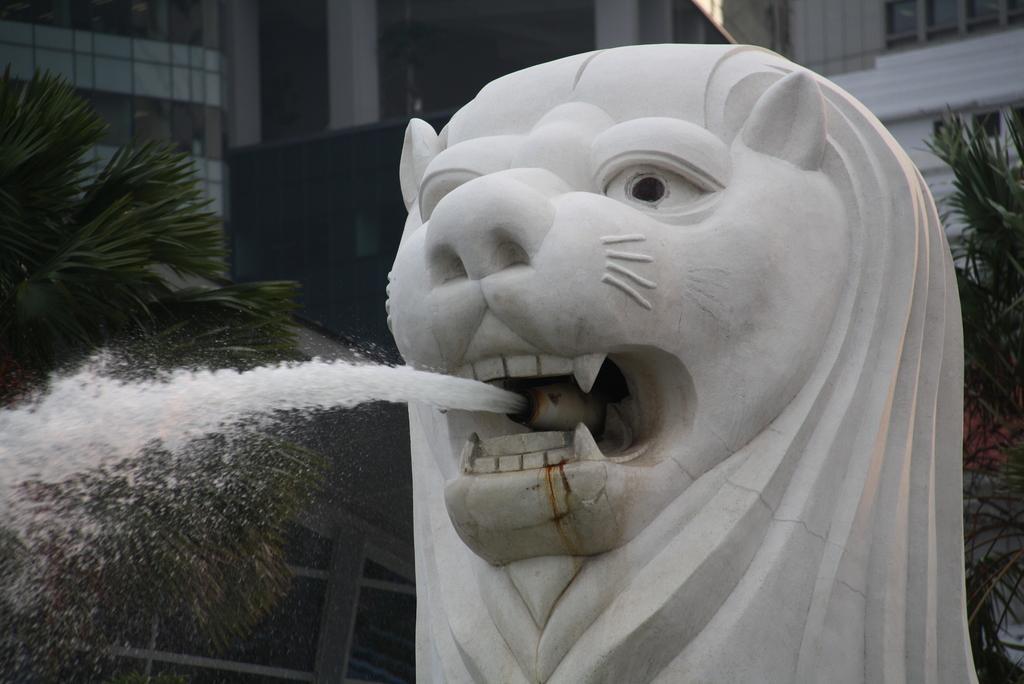Could you give a brief overview of what you see in this image? In this picture in the middle, we can see a statue from which flow of water from its mouth. In the background, we can see some trees, buildings, glass window. 